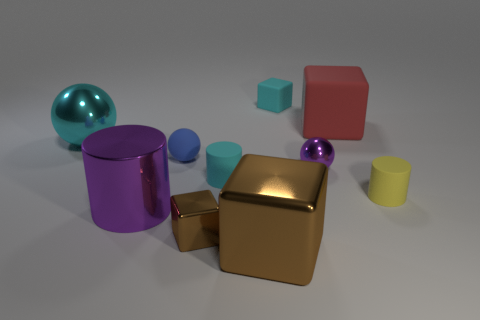There is a small object that is the same material as the small brown block; what is its shape?
Ensure brevity in your answer.  Sphere. Are there any other things that are the same color as the large cylinder?
Offer a terse response. Yes. What color is the rubber block that is to the right of the purple shiny thing on the right side of the large shiny cylinder?
Your answer should be compact. Red. What number of tiny things are cubes or cyan rubber things?
Provide a short and direct response. 3. What material is the other tiny object that is the same shape as the small purple thing?
Your answer should be compact. Rubber. Are there any other things that are the same material as the large red thing?
Offer a very short reply. Yes. The big rubber object has what color?
Give a very brief answer. Red. Does the big rubber thing have the same color as the small rubber sphere?
Ensure brevity in your answer.  No. What number of large red cubes are behind the small cube behind the cyan sphere?
Make the answer very short. 0. There is a shiny object that is in front of the big ball and behind the tiny yellow rubber cylinder; how big is it?
Provide a succinct answer. Small. 